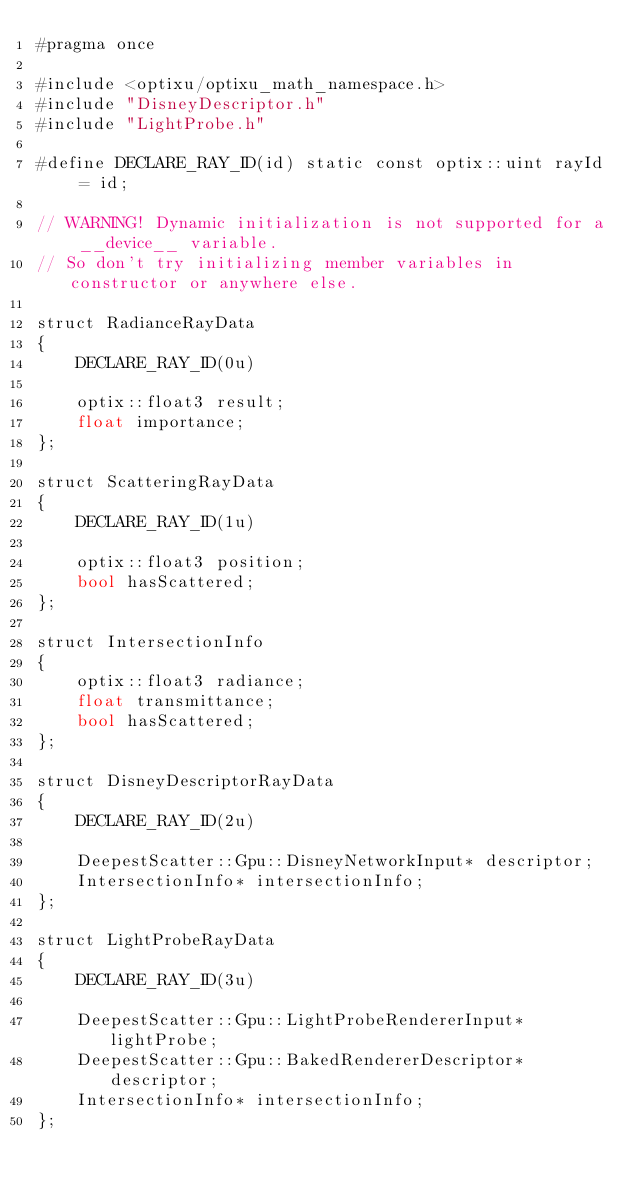<code> <loc_0><loc_0><loc_500><loc_500><_Cuda_>#pragma once

#include <optixu/optixu_math_namespace.h>
#include "DisneyDescriptor.h"
#include "LightProbe.h"

#define DECLARE_RAY_ID(id) static const optix::uint rayId = id;

// WARNING! Dynamic initialization is not supported for a __device__ variable. 
// So don't try initializing member variables in constructor or anywhere else.

struct RadianceRayData
{
    DECLARE_RAY_ID(0u)

    optix::float3 result;
    float importance;
};

struct ScatteringRayData
{
    DECLARE_RAY_ID(1u)

    optix::float3 position;
    bool hasScattered;
};

struct IntersectionInfo
{
    optix::float3 radiance;
    float transmittance;
    bool hasScattered;
};

struct DisneyDescriptorRayData
{
    DECLARE_RAY_ID(2u)

    DeepestScatter::Gpu::DisneyNetworkInput* descriptor;
    IntersectionInfo* intersectionInfo;
};

struct LightProbeRayData
{
    DECLARE_RAY_ID(3u)

    DeepestScatter::Gpu::LightProbeRendererInput* lightProbe;
    DeepestScatter::Gpu::BakedRendererDescriptor* descriptor;
    IntersectionInfo* intersectionInfo;
};</code> 